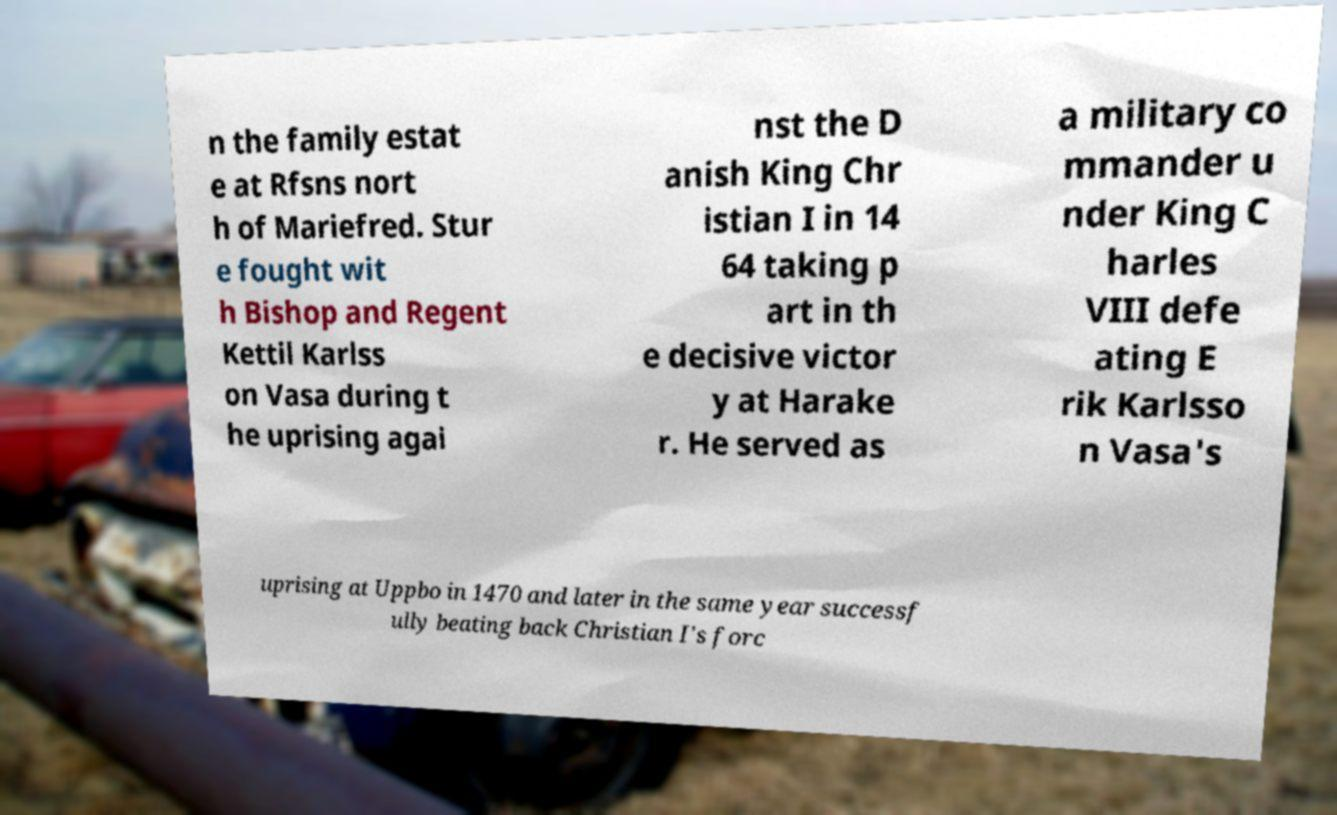Could you extract and type out the text from this image? n the family estat e at Rfsns nort h of Mariefred. Stur e fought wit h Bishop and Regent Kettil Karlss on Vasa during t he uprising agai nst the D anish King Chr istian I in 14 64 taking p art in th e decisive victor y at Harake r. He served as a military co mmander u nder King C harles VIII defe ating E rik Karlsso n Vasa's uprising at Uppbo in 1470 and later in the same year successf ully beating back Christian I's forc 